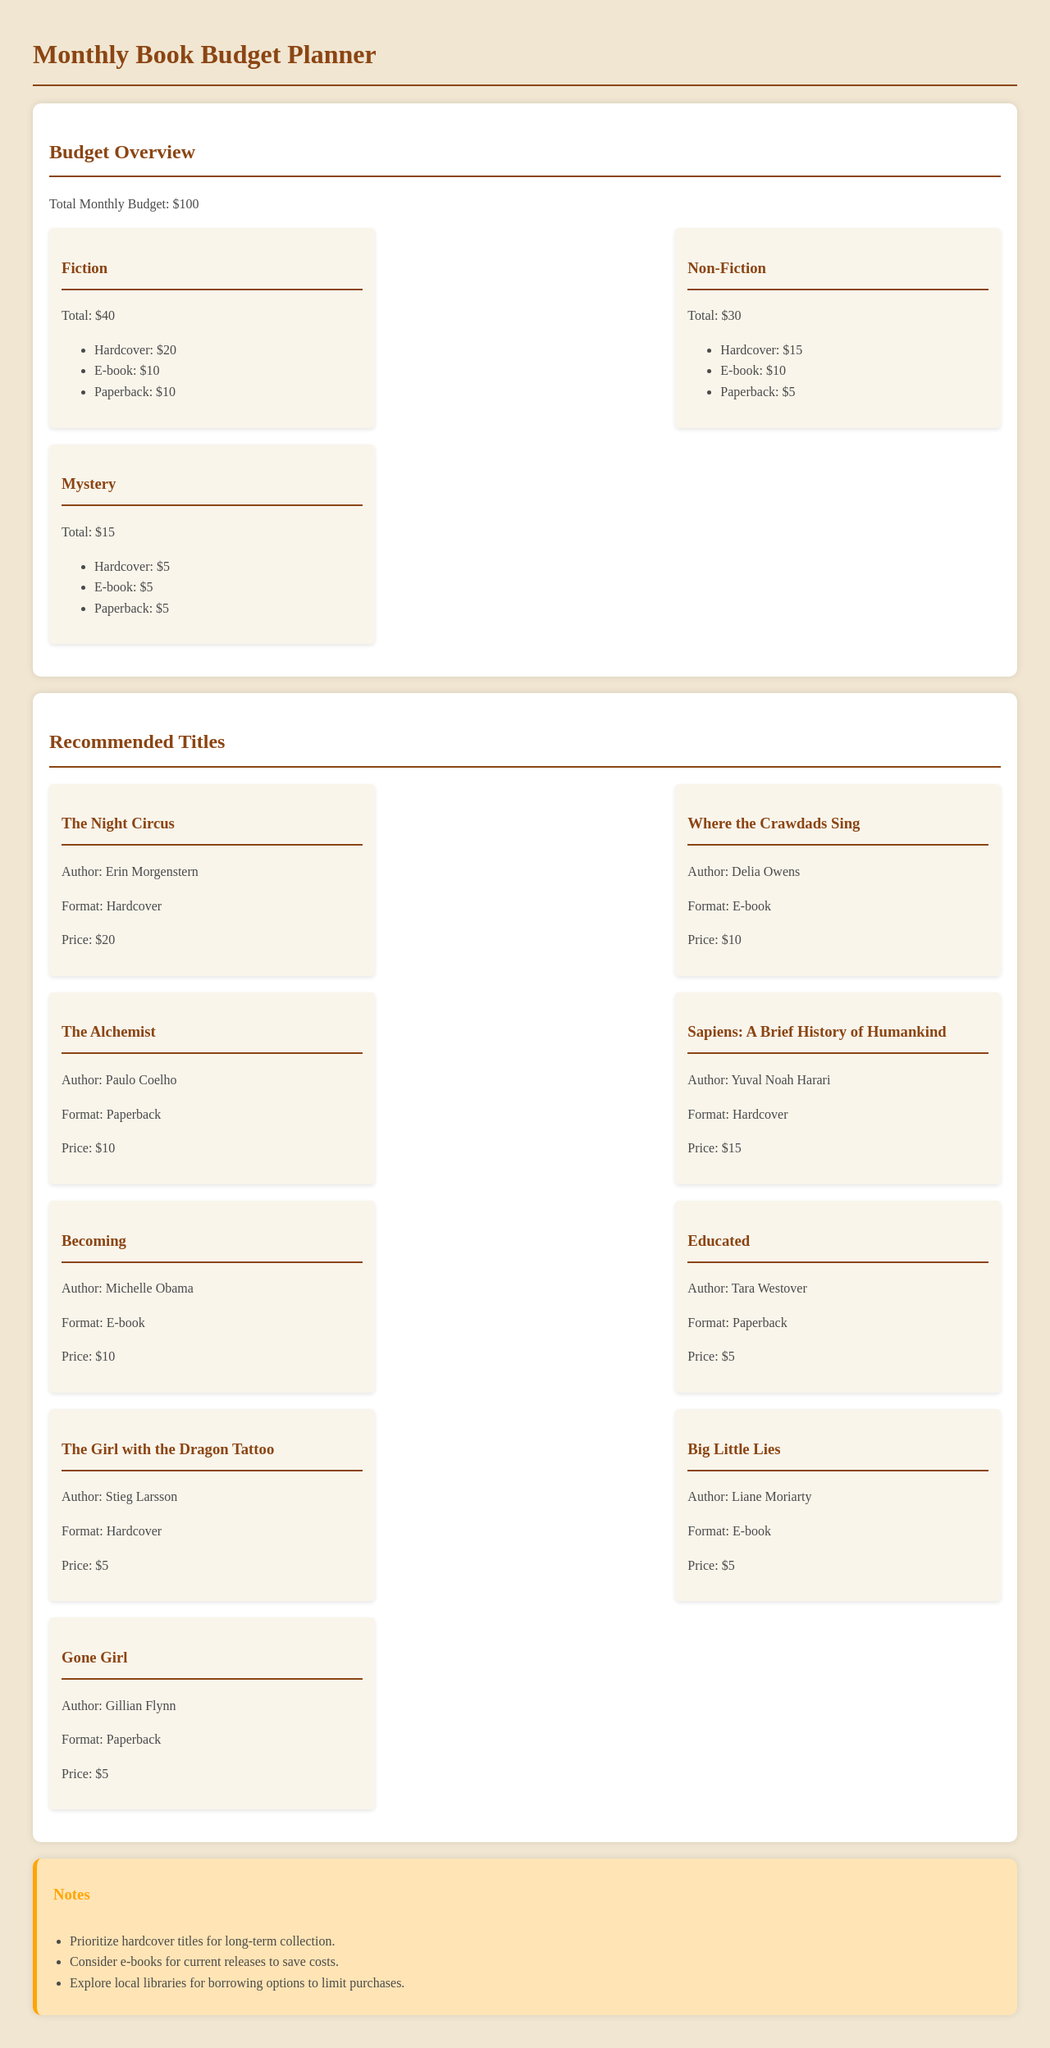what is the total monthly budget? The total monthly budget is explicitly stated in the document.
Answer: $100 how much is allocated for Fiction? The budget overview shows how much is allocated for each category, including Fiction.
Answer: $40 which book is written by Erin Morgenstern? The document includes a list of recommended titles with their authors.
Answer: The Night Circus what is the price of the E-book format for Becoming? The document mentions the price of the book Becoming and its format.
Answer: $10 how much is allocated for Non-Fiction in hardcover? The breakdown shows the allocation for Non-Fiction by format.
Answer: $15 which genre has the highest allocation? The budget overview lists allocations for each genre allowing a comparison to find the highest one.
Answer: Fiction how many books are in the recommended titles section? By counting the individual book items in the document, you can answer this question.
Answer: 9 what is the format of The Alchemist? The format for each recommended title is specified in the document.
Answer: Paperback what should be prioritized according to the notes? The notes section provides advice on book collection priorities.
Answer: Hardcover titles 